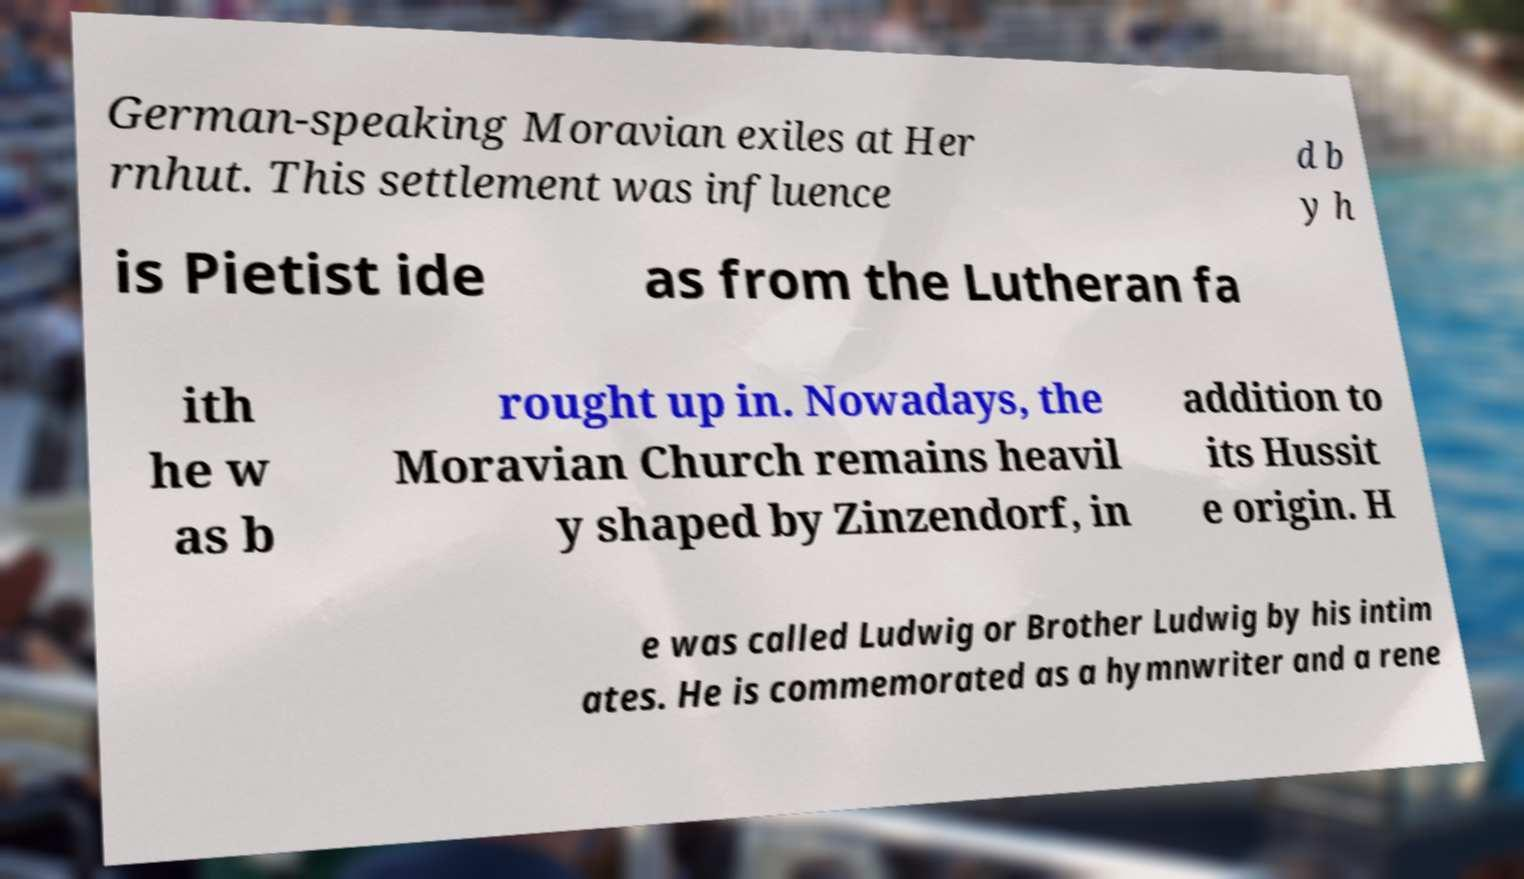Can you read and provide the text displayed in the image?This photo seems to have some interesting text. Can you extract and type it out for me? German-speaking Moravian exiles at Her rnhut. This settlement was influence d b y h is Pietist ide as from the Lutheran fa ith he w as b rought up in. Nowadays, the Moravian Church remains heavil y shaped by Zinzendorf, in addition to its Hussit e origin. H e was called Ludwig or Brother Ludwig by his intim ates. He is commemorated as a hymnwriter and a rene 